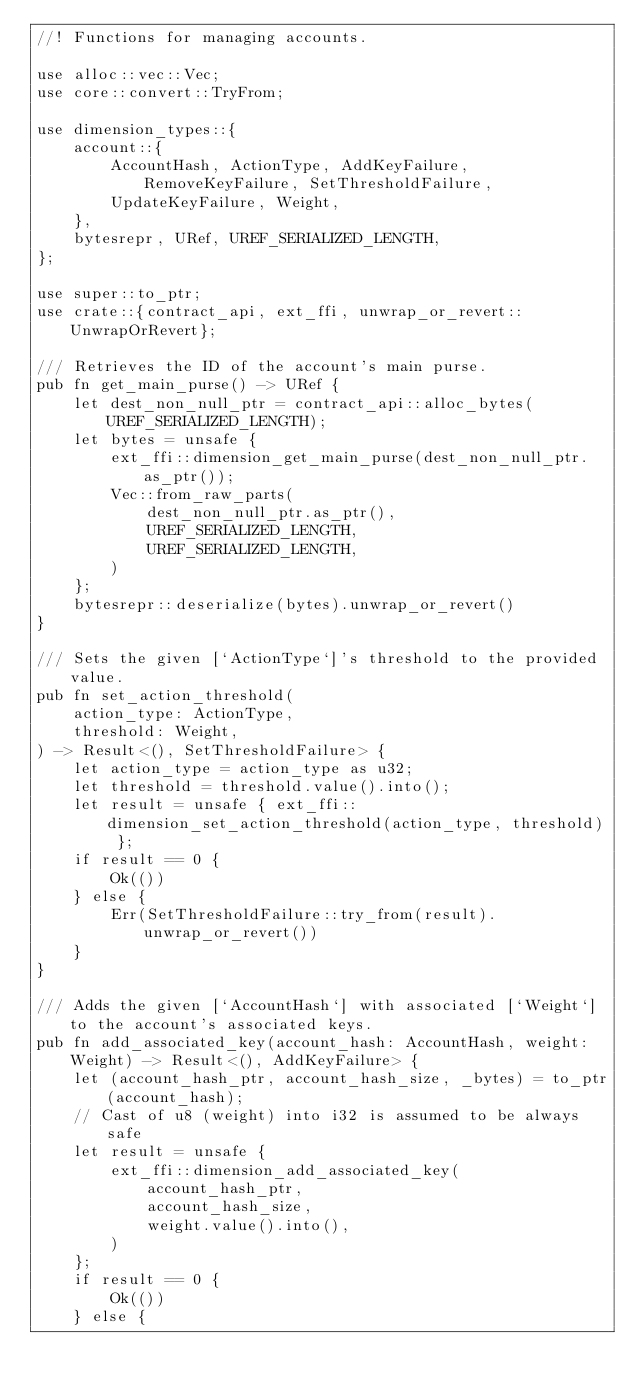<code> <loc_0><loc_0><loc_500><loc_500><_Rust_>//! Functions for managing accounts.

use alloc::vec::Vec;
use core::convert::TryFrom;

use dimension_types::{
    account::{
        AccountHash, ActionType, AddKeyFailure, RemoveKeyFailure, SetThresholdFailure,
        UpdateKeyFailure, Weight,
    },
    bytesrepr, URef, UREF_SERIALIZED_LENGTH,
};

use super::to_ptr;
use crate::{contract_api, ext_ffi, unwrap_or_revert::UnwrapOrRevert};

/// Retrieves the ID of the account's main purse.
pub fn get_main_purse() -> URef {
    let dest_non_null_ptr = contract_api::alloc_bytes(UREF_SERIALIZED_LENGTH);
    let bytes = unsafe {
        ext_ffi::dimension_get_main_purse(dest_non_null_ptr.as_ptr());
        Vec::from_raw_parts(
            dest_non_null_ptr.as_ptr(),
            UREF_SERIALIZED_LENGTH,
            UREF_SERIALIZED_LENGTH,
        )
    };
    bytesrepr::deserialize(bytes).unwrap_or_revert()
}

/// Sets the given [`ActionType`]'s threshold to the provided value.
pub fn set_action_threshold(
    action_type: ActionType,
    threshold: Weight,
) -> Result<(), SetThresholdFailure> {
    let action_type = action_type as u32;
    let threshold = threshold.value().into();
    let result = unsafe { ext_ffi::dimension_set_action_threshold(action_type, threshold) };
    if result == 0 {
        Ok(())
    } else {
        Err(SetThresholdFailure::try_from(result).unwrap_or_revert())
    }
}

/// Adds the given [`AccountHash`] with associated [`Weight`] to the account's associated keys.
pub fn add_associated_key(account_hash: AccountHash, weight: Weight) -> Result<(), AddKeyFailure> {
    let (account_hash_ptr, account_hash_size, _bytes) = to_ptr(account_hash);
    // Cast of u8 (weight) into i32 is assumed to be always safe
    let result = unsafe {
        ext_ffi::dimension_add_associated_key(
            account_hash_ptr,
            account_hash_size,
            weight.value().into(),
        )
    };
    if result == 0 {
        Ok(())
    } else {</code> 